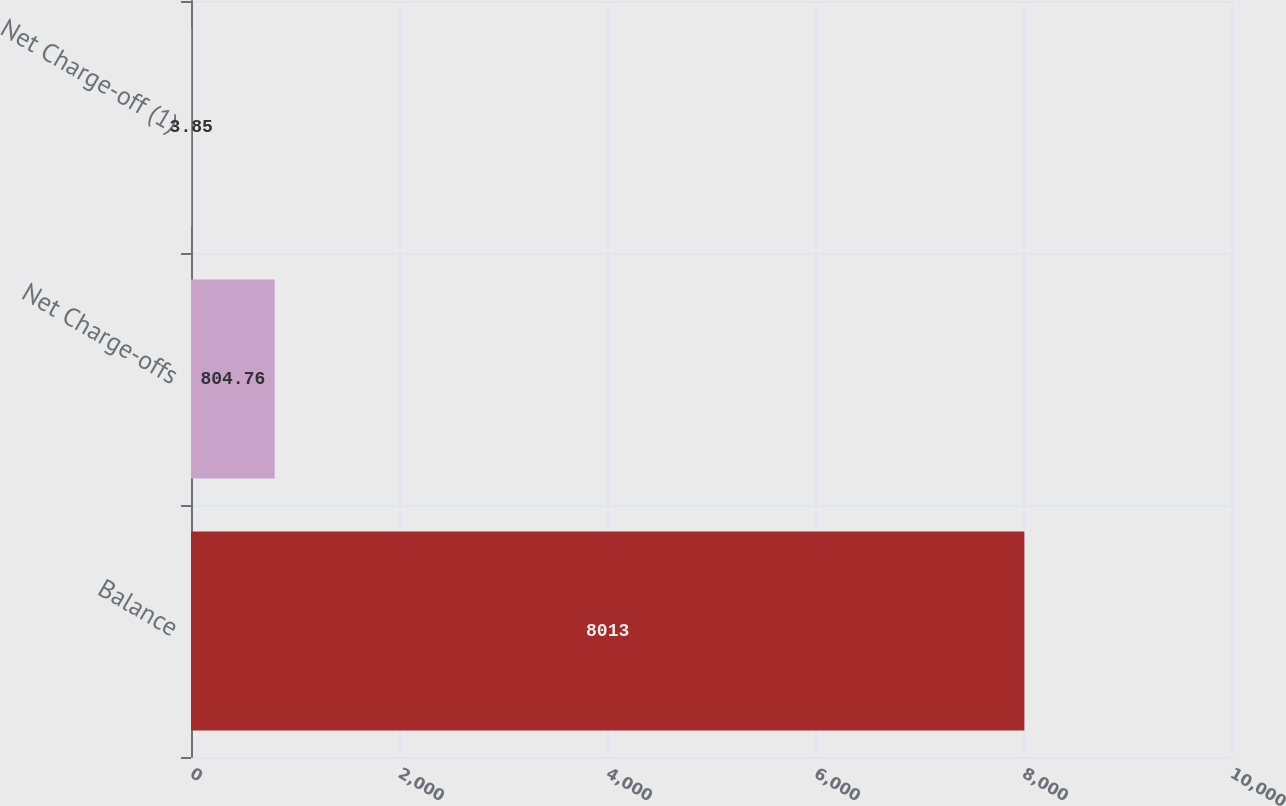Convert chart. <chart><loc_0><loc_0><loc_500><loc_500><bar_chart><fcel>Balance<fcel>Net Charge-offs<fcel>Net Charge-off (1)<nl><fcel>8013<fcel>804.76<fcel>3.85<nl></chart> 